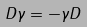Convert formula to latex. <formula><loc_0><loc_0><loc_500><loc_500>D \gamma = - \gamma D</formula> 